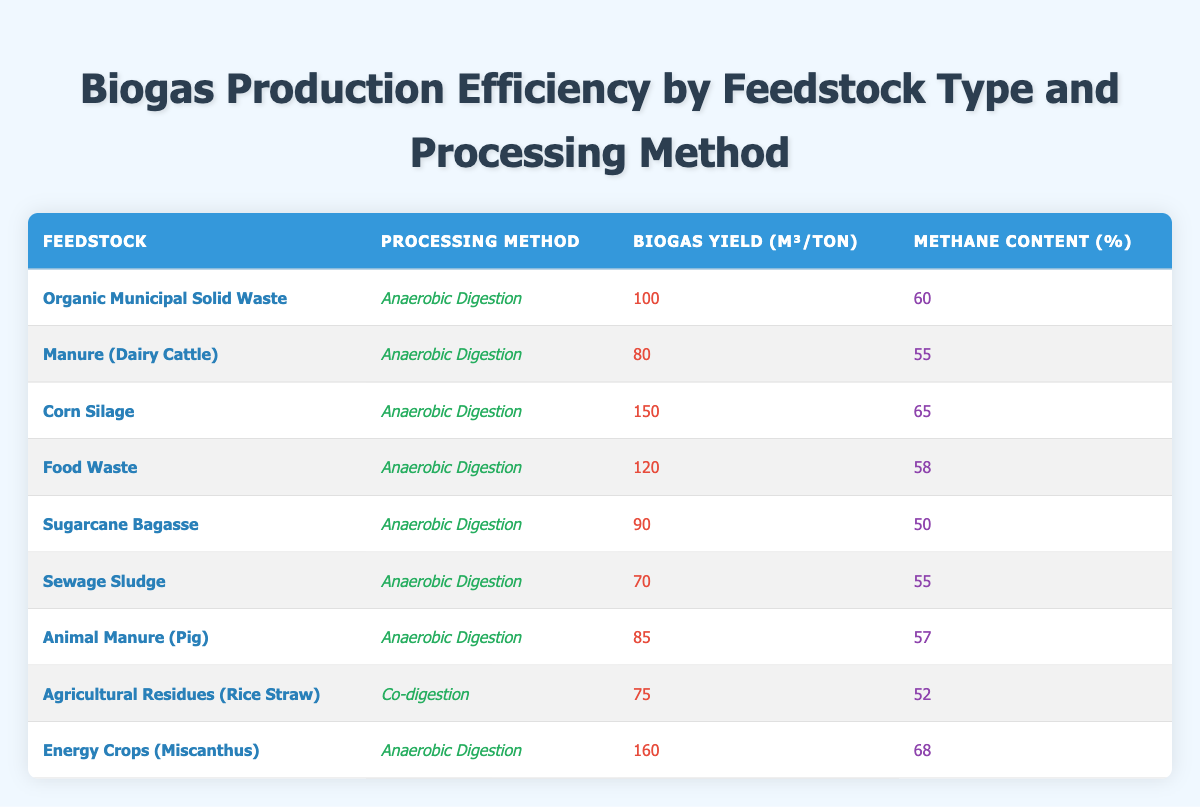What is the biogas yield for Corn Silage? The biogas yield for Corn Silage is stated directly in the table, which shows it to be 150 m³/ton.
Answer: 150 m³/ton Which feedstock has the highest methane content? Upon reviewing the table, Energy Crops (Miscanthus) shows the highest methane content percentage at 68%.
Answer: 68% Does Sugarcane Bagasse have a higher biogas yield than Agricultural Residues (Rice Straw)? By comparing the biogas yields, Sugarcane Bagasse shows a yield of 90 m³/ton, while Agricultural Residues (Rice Straw) has a yield of 75 m³/ton. Therefore, Sugarcane Bagasse has a higher yield.
Answer: Yes What is the average methane content of the feedstocks processed using Anaerobic Digestion? To find the average methane content, sum the methane content percentages for each feedstock processed with Anaerobic Digestion: (60 + 55 + 65 + 58 + 50 + 55 + 57 + 68) =  65, and then divide by the number of entries (8), resulting in an average of 65/8 = 57.5%.
Answer: 57.5% Is the biogas yield for Manure (Dairy Cattle) lower than that for Food Waste? Looking at the biogas yields, Manure (Dairy Cattle) has a yield of 80 m³/ton, while Food Waste has a yield of 120 m³/ton. Since 80 is indeed lower than 120, the answer is yes.
Answer: Yes 